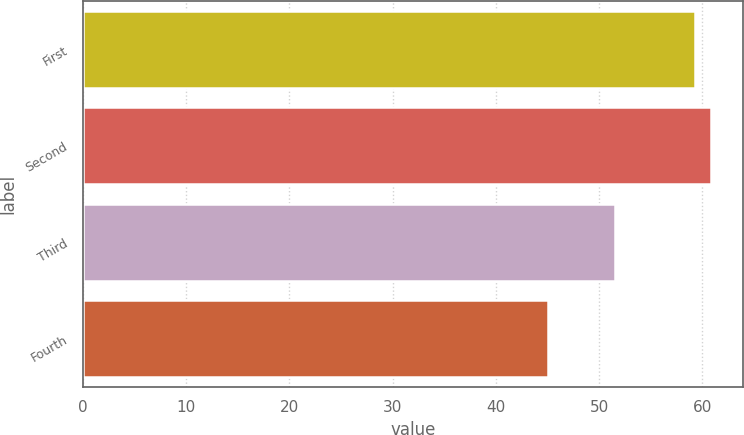<chart> <loc_0><loc_0><loc_500><loc_500><bar_chart><fcel>First<fcel>Second<fcel>Third<fcel>Fourth<nl><fcel>59.33<fcel>60.88<fcel>51.51<fcel>45.04<nl></chart> 